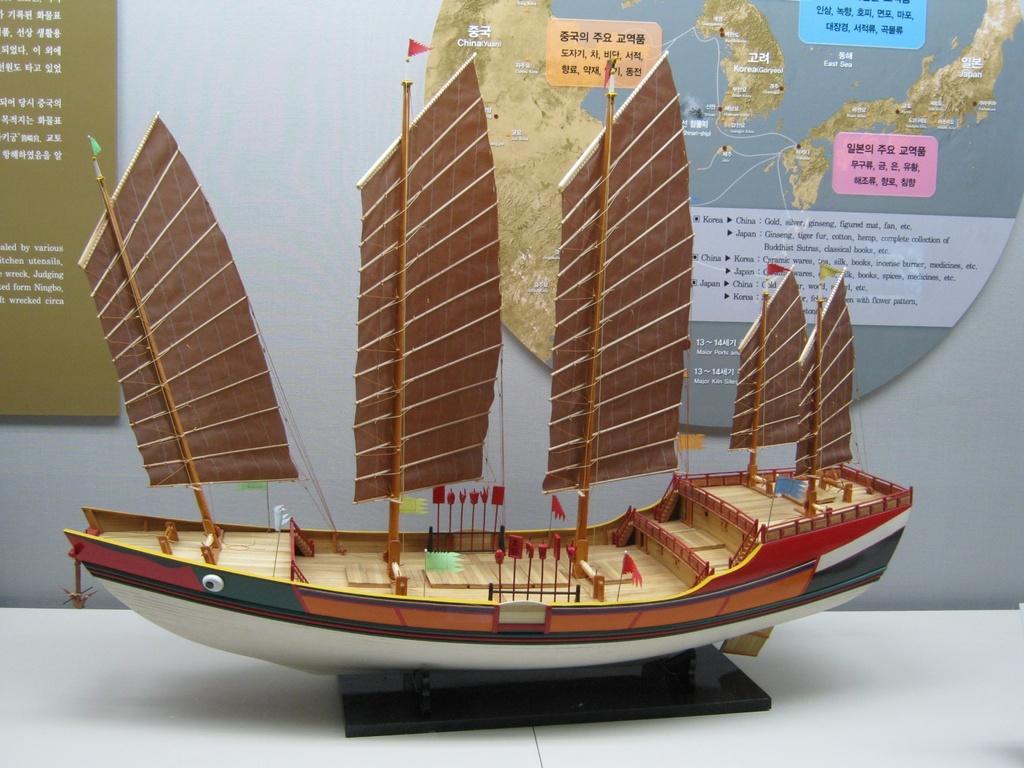Could you give a brief overview of what you see in this image? In this picture, we can see a toy boat with a black color object on the white surface and in the background we can see the wall and some posters with some text and images on it. 